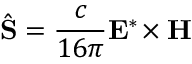<formula> <loc_0><loc_0><loc_500><loc_500>\hat { S } = \frac { c } { 1 6 \pi } E ^ { * } \, \times H</formula> 